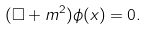Convert formula to latex. <formula><loc_0><loc_0><loc_500><loc_500>( \Box + m ^ { 2 } ) \phi ( x ) = 0 .</formula> 